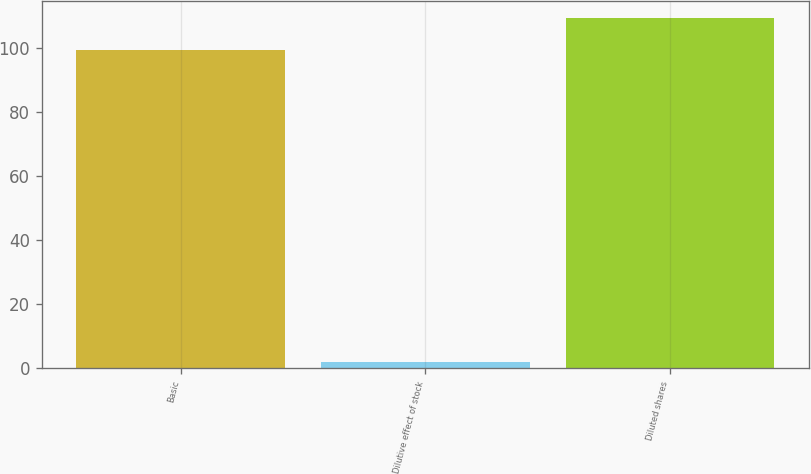<chart> <loc_0><loc_0><loc_500><loc_500><bar_chart><fcel>Basic<fcel>Dilutive effect of stock<fcel>Diluted shares<nl><fcel>99.2<fcel>2.1<fcel>109.12<nl></chart> 